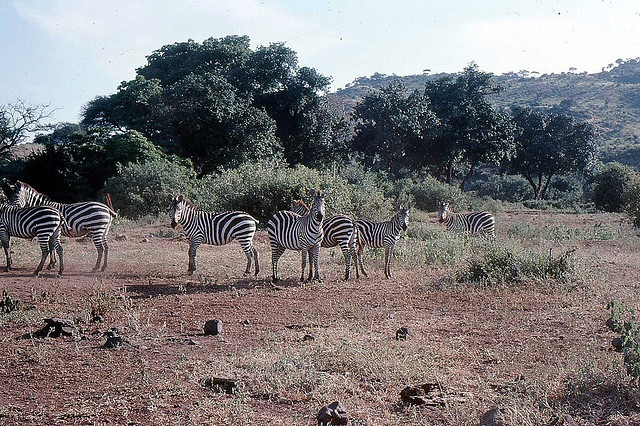Describe the objects in this image and their specific colors. I can see zebra in lightblue, black, gray, darkgray, and lightgray tones, zebra in lightblue, black, gray, darkgray, and lightgray tones, zebra in lightblue, black, gray, darkgray, and lightgray tones, zebra in lightblue, black, gray, darkgray, and lightgray tones, and zebra in lightblue, black, gray, darkgray, and lightgray tones in this image. 